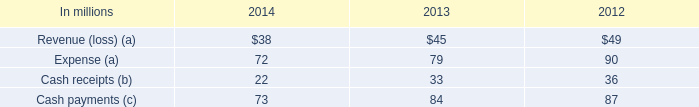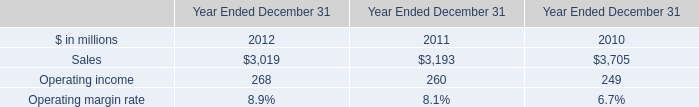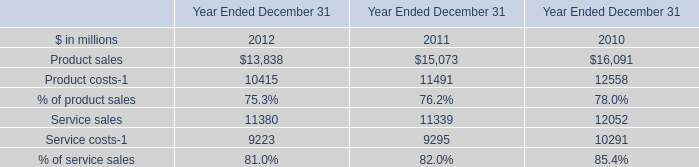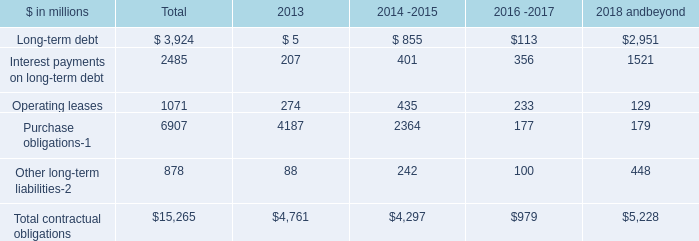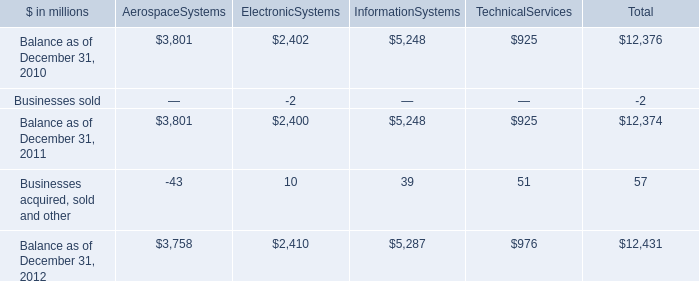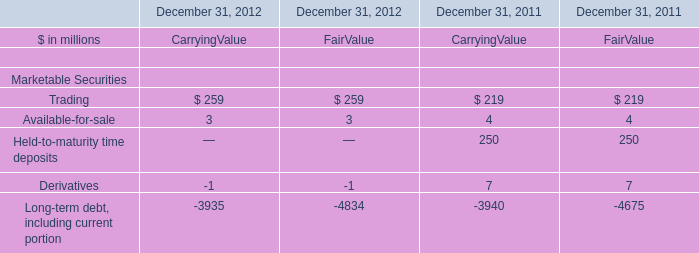What is the sum of CarryingValue in the range of 10 and 300 in 2011? (in million) 
Computations: (219 + 250)
Answer: 469.0. 